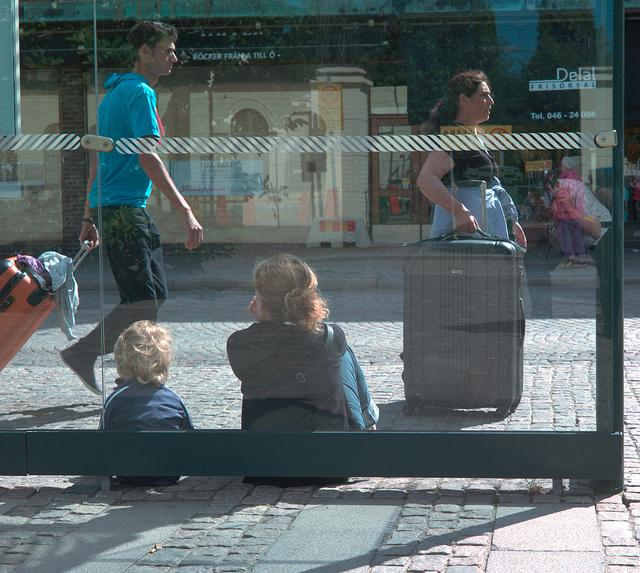Why is the white lines on the glass?

Choices:
A) visibility
B) height restriction
C) decoration
D) measurement visibility 